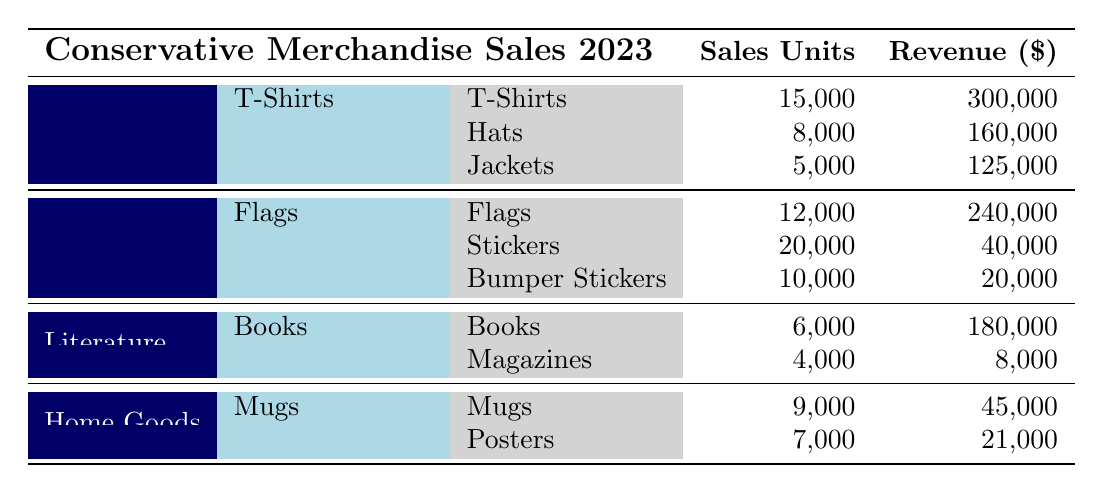What is the total sales revenue from Apparel merchandise? The sales revenue for Apparel is broken down into T-Shirts (300,000), Hats (160,000), and Jackets (125,000). Adding these together: 300,000 + 160,000 + 125,000 = 585,000.
Answer: 585,000 Which item had the highest sales units in Accessories? Among the items listed under Accessories, we have Flags (12,000), Stickers (20,000), and Bumper Stickers (10,000). The highest sales units are from Stickers at 20,000.
Answer: Stickers Did any item in Literature category exceed sales of 5,000 units? The Literature category includes Books (6,000) and Magazines (4,000). Books exceeded 5,000 units with a total sales of 6,000 units.
Answer: Yes What is the average revenue of items in Home Goods? The revenue for Home Goods includes Mugs (45,000) and Posters (21,000). The total revenue is 45,000 + 21,000 = 66,000. There are 2 items, so the average revenue is 66,000 / 2 = 33,000.
Answer: 33,000 How many total units were sold across all categories? For total units, we sum up the sales units from each category: T-Shirts (15,000) + Hats (8,000) + Jackets (5,000) + Flags (12,000) + Stickers (20,000) + Bumper Stickers (10,000) + Books (6,000) + Magazines (4,000) + Mugs (9,000) + Posters (7,000) = 292,000.
Answer: 292,000 Which category generated the lowest revenue? The revenue for each category is as follows: Apparel (585,000), Accessories (300,000), Literature (188,000), Home Goods (66,000). Comparing these, Home Goods generated the lowest revenue at 66,000.
Answer: Home Goods How much more revenue did Accessories generate compared to Literature? Accessories generated 300,000 and Literature generated 188,000. The difference is 300,000 - 188,000 = 112,000, indicating Accessories generated 112,000 more than Literature.
Answer: 112,000 Were more units sold in T-Shirts than in Books? T-Shirts sold 15,000 units while Books sold 6,000 units. Since 15,000 is greater than 6,000, T-Shirts indeed sold more units.
Answer: Yes 